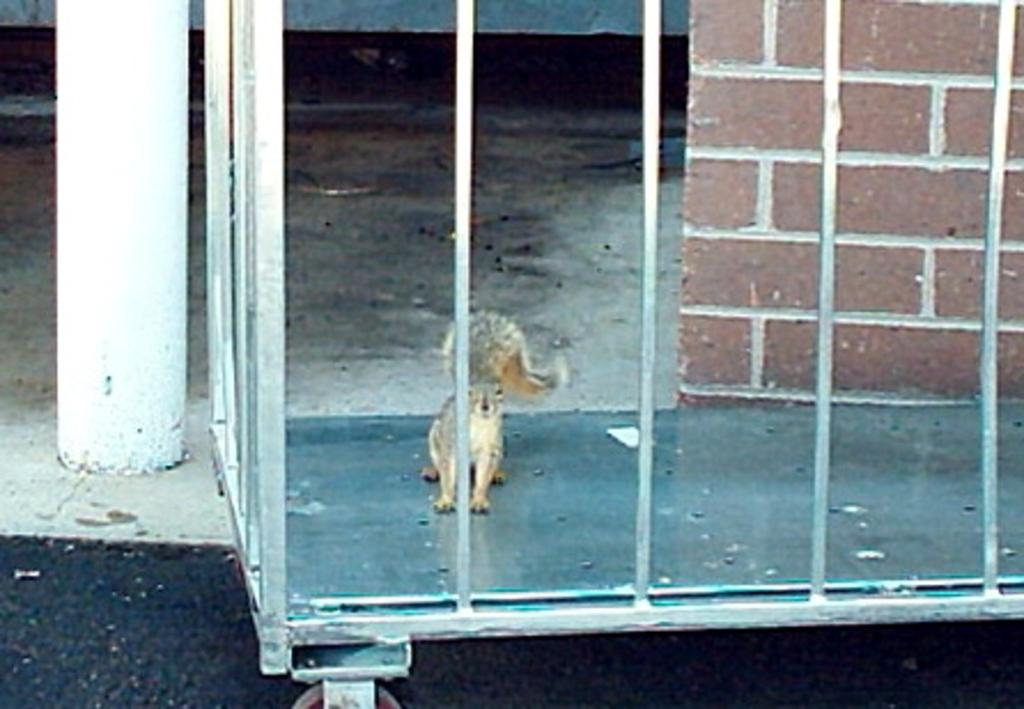What animal can be seen in the image? There is a squirrel in the image. What type of surface is the squirrel on? The squirrel is on an iron surface. What is the main object in the image? There is a grill in the image. What can be seen in the background of the image? There is a wall and a rod in the background of the image. What type of bead is the squirrel holding in the image? There is no bead present in the image; the squirrel is not holding anything. How many bottles can be seen in the image? There are no bottles present in the image. 